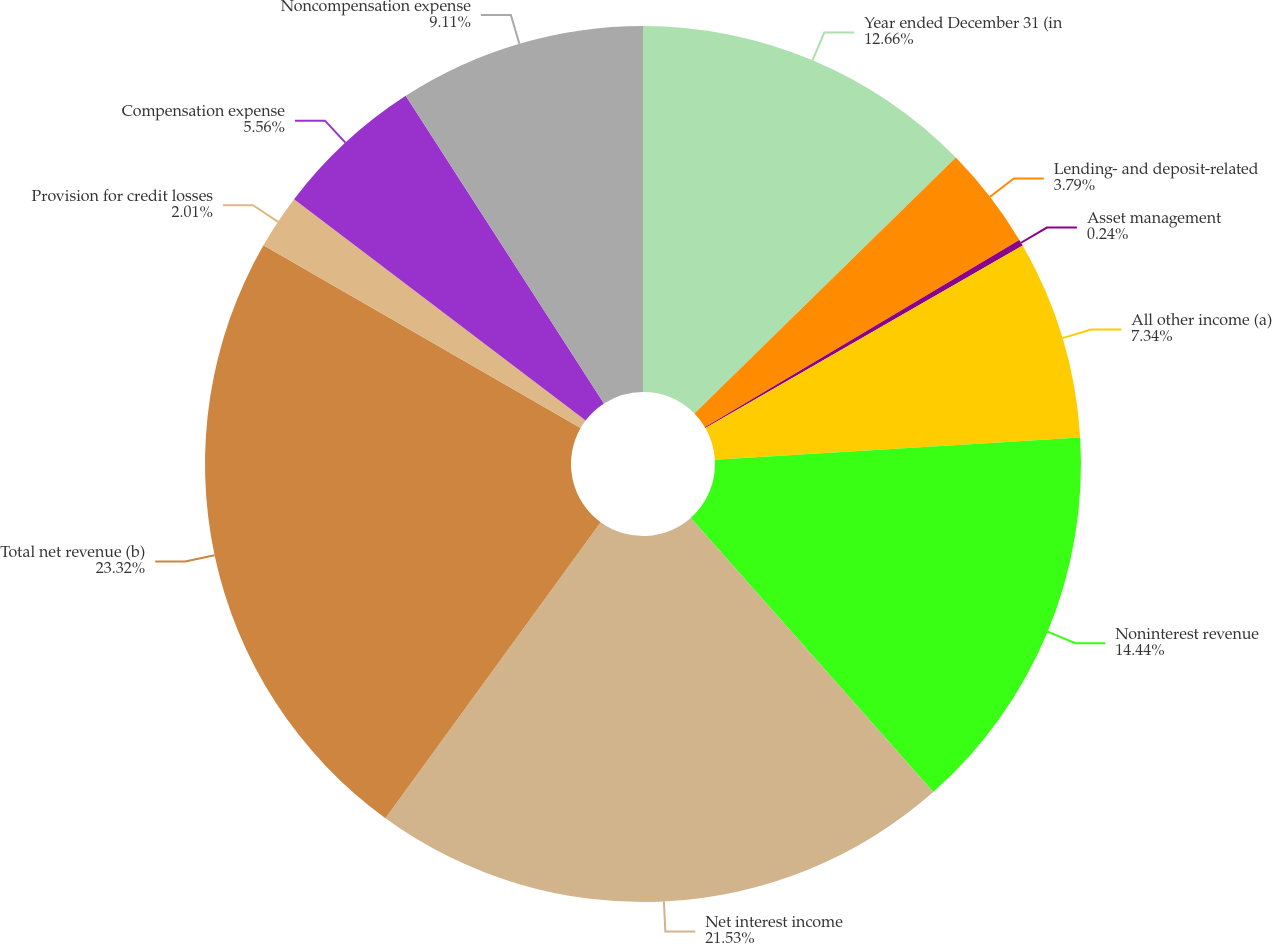Convert chart to OTSL. <chart><loc_0><loc_0><loc_500><loc_500><pie_chart><fcel>Year ended December 31 (in<fcel>Lending- and deposit-related<fcel>Asset management<fcel>All other income (a)<fcel>Noninterest revenue<fcel>Net interest income<fcel>Total net revenue (b)<fcel>Provision for credit losses<fcel>Compensation expense<fcel>Noncompensation expense<nl><fcel>12.66%<fcel>3.79%<fcel>0.24%<fcel>7.34%<fcel>14.44%<fcel>21.53%<fcel>23.31%<fcel>2.01%<fcel>5.56%<fcel>9.11%<nl></chart> 